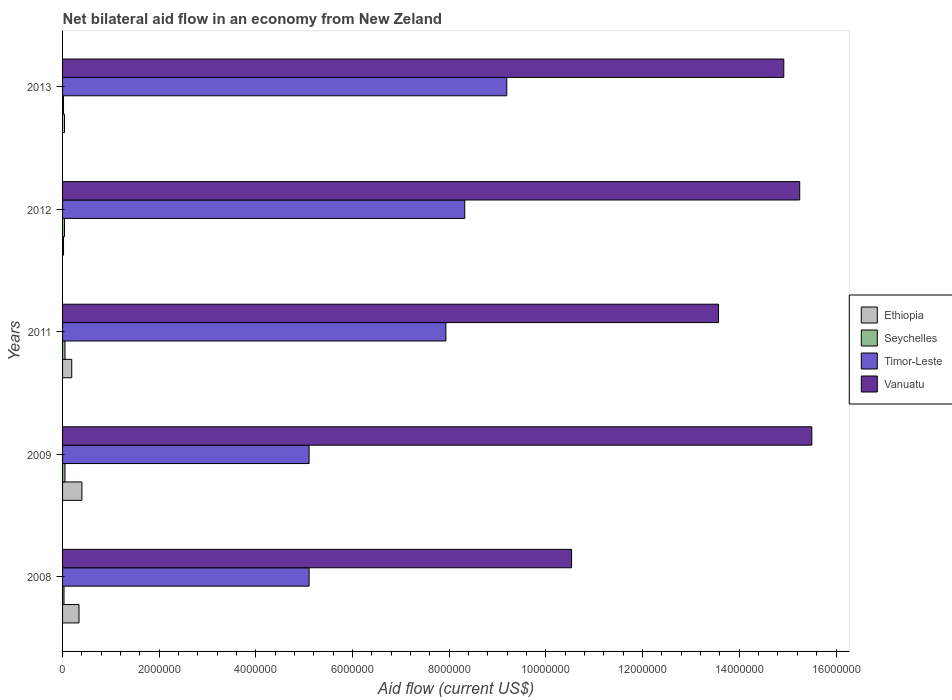How many different coloured bars are there?
Your answer should be compact. 4. Are the number of bars per tick equal to the number of legend labels?
Your response must be concise. Yes. Are the number of bars on each tick of the Y-axis equal?
Offer a very short reply. Yes. How many bars are there on the 1st tick from the top?
Your response must be concise. 4. What is the label of the 1st group of bars from the top?
Your answer should be compact. 2013. In how many cases, is the number of bars for a given year not equal to the number of legend labels?
Provide a short and direct response. 0. What is the net bilateral aid flow in Vanuatu in 2011?
Your response must be concise. 1.36e+07. Across all years, what is the maximum net bilateral aid flow in Vanuatu?
Make the answer very short. 1.55e+07. Across all years, what is the minimum net bilateral aid flow in Vanuatu?
Provide a succinct answer. 1.05e+07. What is the difference between the net bilateral aid flow in Timor-Leste in 2008 and that in 2011?
Make the answer very short. -2.83e+06. What is the difference between the net bilateral aid flow in Timor-Leste in 2009 and the net bilateral aid flow in Seychelles in 2012?
Make the answer very short. 5.06e+06. What is the average net bilateral aid flow in Timor-Leste per year?
Provide a short and direct response. 7.13e+06. In the year 2012, what is the difference between the net bilateral aid flow in Ethiopia and net bilateral aid flow in Vanuatu?
Keep it short and to the point. -1.52e+07. In how many years, is the net bilateral aid flow in Seychelles greater than 4400000 US$?
Give a very brief answer. 0. What is the ratio of the net bilateral aid flow in Timor-Leste in 2011 to that in 2012?
Ensure brevity in your answer.  0.95. What is the difference between the highest and the second highest net bilateral aid flow in Seychelles?
Make the answer very short. 0. What is the difference between the highest and the lowest net bilateral aid flow in Timor-Leste?
Offer a very short reply. 4.09e+06. Is the sum of the net bilateral aid flow in Timor-Leste in 2009 and 2012 greater than the maximum net bilateral aid flow in Ethiopia across all years?
Make the answer very short. Yes. Is it the case that in every year, the sum of the net bilateral aid flow in Seychelles and net bilateral aid flow in Ethiopia is greater than the sum of net bilateral aid flow in Vanuatu and net bilateral aid flow in Timor-Leste?
Your response must be concise. No. What does the 4th bar from the top in 2013 represents?
Your answer should be very brief. Ethiopia. What does the 3rd bar from the bottom in 2009 represents?
Your answer should be very brief. Timor-Leste. What is the difference between two consecutive major ticks on the X-axis?
Make the answer very short. 2.00e+06. Where does the legend appear in the graph?
Provide a succinct answer. Center right. How many legend labels are there?
Keep it short and to the point. 4. How are the legend labels stacked?
Give a very brief answer. Vertical. What is the title of the graph?
Your answer should be very brief. Net bilateral aid flow in an economy from New Zeland. Does "Qatar" appear as one of the legend labels in the graph?
Ensure brevity in your answer.  No. What is the label or title of the X-axis?
Offer a terse response. Aid flow (current US$). What is the label or title of the Y-axis?
Your answer should be very brief. Years. What is the Aid flow (current US$) of Timor-Leste in 2008?
Your answer should be compact. 5.10e+06. What is the Aid flow (current US$) in Vanuatu in 2008?
Keep it short and to the point. 1.05e+07. What is the Aid flow (current US$) in Seychelles in 2009?
Your answer should be very brief. 5.00e+04. What is the Aid flow (current US$) in Timor-Leste in 2009?
Ensure brevity in your answer.  5.10e+06. What is the Aid flow (current US$) in Vanuatu in 2009?
Make the answer very short. 1.55e+07. What is the Aid flow (current US$) in Ethiopia in 2011?
Your answer should be very brief. 1.90e+05. What is the Aid flow (current US$) of Timor-Leste in 2011?
Make the answer very short. 7.93e+06. What is the Aid flow (current US$) in Vanuatu in 2011?
Give a very brief answer. 1.36e+07. What is the Aid flow (current US$) in Ethiopia in 2012?
Ensure brevity in your answer.  2.00e+04. What is the Aid flow (current US$) in Timor-Leste in 2012?
Your answer should be very brief. 8.32e+06. What is the Aid flow (current US$) in Vanuatu in 2012?
Ensure brevity in your answer.  1.52e+07. What is the Aid flow (current US$) of Seychelles in 2013?
Your answer should be compact. 2.00e+04. What is the Aid flow (current US$) of Timor-Leste in 2013?
Make the answer very short. 9.19e+06. What is the Aid flow (current US$) of Vanuatu in 2013?
Offer a terse response. 1.49e+07. Across all years, what is the maximum Aid flow (current US$) of Timor-Leste?
Provide a succinct answer. 9.19e+06. Across all years, what is the maximum Aid flow (current US$) of Vanuatu?
Offer a very short reply. 1.55e+07. Across all years, what is the minimum Aid flow (current US$) of Ethiopia?
Your answer should be compact. 2.00e+04. Across all years, what is the minimum Aid flow (current US$) in Seychelles?
Provide a succinct answer. 2.00e+04. Across all years, what is the minimum Aid flow (current US$) in Timor-Leste?
Your response must be concise. 5.10e+06. Across all years, what is the minimum Aid flow (current US$) in Vanuatu?
Give a very brief answer. 1.05e+07. What is the total Aid flow (current US$) of Ethiopia in the graph?
Provide a short and direct response. 9.90e+05. What is the total Aid flow (current US$) in Seychelles in the graph?
Make the answer very short. 1.90e+05. What is the total Aid flow (current US$) of Timor-Leste in the graph?
Ensure brevity in your answer.  3.56e+07. What is the total Aid flow (current US$) of Vanuatu in the graph?
Offer a terse response. 6.98e+07. What is the difference between the Aid flow (current US$) in Ethiopia in 2008 and that in 2009?
Ensure brevity in your answer.  -6.00e+04. What is the difference between the Aid flow (current US$) in Vanuatu in 2008 and that in 2009?
Your answer should be very brief. -4.97e+06. What is the difference between the Aid flow (current US$) in Ethiopia in 2008 and that in 2011?
Give a very brief answer. 1.50e+05. What is the difference between the Aid flow (current US$) of Seychelles in 2008 and that in 2011?
Your answer should be compact. -2.00e+04. What is the difference between the Aid flow (current US$) of Timor-Leste in 2008 and that in 2011?
Offer a very short reply. -2.83e+06. What is the difference between the Aid flow (current US$) in Vanuatu in 2008 and that in 2011?
Offer a very short reply. -3.04e+06. What is the difference between the Aid flow (current US$) of Seychelles in 2008 and that in 2012?
Offer a very short reply. -10000. What is the difference between the Aid flow (current US$) in Timor-Leste in 2008 and that in 2012?
Your answer should be very brief. -3.22e+06. What is the difference between the Aid flow (current US$) of Vanuatu in 2008 and that in 2012?
Offer a terse response. -4.72e+06. What is the difference between the Aid flow (current US$) of Timor-Leste in 2008 and that in 2013?
Ensure brevity in your answer.  -4.09e+06. What is the difference between the Aid flow (current US$) in Vanuatu in 2008 and that in 2013?
Offer a very short reply. -4.39e+06. What is the difference between the Aid flow (current US$) in Ethiopia in 2009 and that in 2011?
Ensure brevity in your answer.  2.10e+05. What is the difference between the Aid flow (current US$) in Timor-Leste in 2009 and that in 2011?
Provide a short and direct response. -2.83e+06. What is the difference between the Aid flow (current US$) in Vanuatu in 2009 and that in 2011?
Offer a terse response. 1.93e+06. What is the difference between the Aid flow (current US$) of Ethiopia in 2009 and that in 2012?
Provide a succinct answer. 3.80e+05. What is the difference between the Aid flow (current US$) of Timor-Leste in 2009 and that in 2012?
Your answer should be very brief. -3.22e+06. What is the difference between the Aid flow (current US$) of Ethiopia in 2009 and that in 2013?
Give a very brief answer. 3.60e+05. What is the difference between the Aid flow (current US$) of Timor-Leste in 2009 and that in 2013?
Keep it short and to the point. -4.09e+06. What is the difference between the Aid flow (current US$) in Vanuatu in 2009 and that in 2013?
Make the answer very short. 5.80e+05. What is the difference between the Aid flow (current US$) of Ethiopia in 2011 and that in 2012?
Give a very brief answer. 1.70e+05. What is the difference between the Aid flow (current US$) of Seychelles in 2011 and that in 2012?
Offer a very short reply. 10000. What is the difference between the Aid flow (current US$) in Timor-Leste in 2011 and that in 2012?
Your answer should be very brief. -3.90e+05. What is the difference between the Aid flow (current US$) in Vanuatu in 2011 and that in 2012?
Give a very brief answer. -1.68e+06. What is the difference between the Aid flow (current US$) of Timor-Leste in 2011 and that in 2013?
Ensure brevity in your answer.  -1.26e+06. What is the difference between the Aid flow (current US$) of Vanuatu in 2011 and that in 2013?
Make the answer very short. -1.35e+06. What is the difference between the Aid flow (current US$) of Ethiopia in 2012 and that in 2013?
Make the answer very short. -2.00e+04. What is the difference between the Aid flow (current US$) in Timor-Leste in 2012 and that in 2013?
Offer a very short reply. -8.70e+05. What is the difference between the Aid flow (current US$) in Vanuatu in 2012 and that in 2013?
Your response must be concise. 3.30e+05. What is the difference between the Aid flow (current US$) in Ethiopia in 2008 and the Aid flow (current US$) in Timor-Leste in 2009?
Your answer should be very brief. -4.76e+06. What is the difference between the Aid flow (current US$) in Ethiopia in 2008 and the Aid flow (current US$) in Vanuatu in 2009?
Make the answer very short. -1.52e+07. What is the difference between the Aid flow (current US$) of Seychelles in 2008 and the Aid flow (current US$) of Timor-Leste in 2009?
Your answer should be compact. -5.07e+06. What is the difference between the Aid flow (current US$) in Seychelles in 2008 and the Aid flow (current US$) in Vanuatu in 2009?
Ensure brevity in your answer.  -1.55e+07. What is the difference between the Aid flow (current US$) of Timor-Leste in 2008 and the Aid flow (current US$) of Vanuatu in 2009?
Your response must be concise. -1.04e+07. What is the difference between the Aid flow (current US$) in Ethiopia in 2008 and the Aid flow (current US$) in Seychelles in 2011?
Keep it short and to the point. 2.90e+05. What is the difference between the Aid flow (current US$) in Ethiopia in 2008 and the Aid flow (current US$) in Timor-Leste in 2011?
Give a very brief answer. -7.59e+06. What is the difference between the Aid flow (current US$) of Ethiopia in 2008 and the Aid flow (current US$) of Vanuatu in 2011?
Provide a succinct answer. -1.32e+07. What is the difference between the Aid flow (current US$) of Seychelles in 2008 and the Aid flow (current US$) of Timor-Leste in 2011?
Ensure brevity in your answer.  -7.90e+06. What is the difference between the Aid flow (current US$) of Seychelles in 2008 and the Aid flow (current US$) of Vanuatu in 2011?
Your answer should be very brief. -1.35e+07. What is the difference between the Aid flow (current US$) of Timor-Leste in 2008 and the Aid flow (current US$) of Vanuatu in 2011?
Give a very brief answer. -8.47e+06. What is the difference between the Aid flow (current US$) in Ethiopia in 2008 and the Aid flow (current US$) in Timor-Leste in 2012?
Your answer should be very brief. -7.98e+06. What is the difference between the Aid flow (current US$) of Ethiopia in 2008 and the Aid flow (current US$) of Vanuatu in 2012?
Provide a short and direct response. -1.49e+07. What is the difference between the Aid flow (current US$) of Seychelles in 2008 and the Aid flow (current US$) of Timor-Leste in 2012?
Your response must be concise. -8.29e+06. What is the difference between the Aid flow (current US$) in Seychelles in 2008 and the Aid flow (current US$) in Vanuatu in 2012?
Give a very brief answer. -1.52e+07. What is the difference between the Aid flow (current US$) in Timor-Leste in 2008 and the Aid flow (current US$) in Vanuatu in 2012?
Keep it short and to the point. -1.02e+07. What is the difference between the Aid flow (current US$) of Ethiopia in 2008 and the Aid flow (current US$) of Seychelles in 2013?
Provide a succinct answer. 3.20e+05. What is the difference between the Aid flow (current US$) of Ethiopia in 2008 and the Aid flow (current US$) of Timor-Leste in 2013?
Your response must be concise. -8.85e+06. What is the difference between the Aid flow (current US$) in Ethiopia in 2008 and the Aid flow (current US$) in Vanuatu in 2013?
Keep it short and to the point. -1.46e+07. What is the difference between the Aid flow (current US$) in Seychelles in 2008 and the Aid flow (current US$) in Timor-Leste in 2013?
Your answer should be very brief. -9.16e+06. What is the difference between the Aid flow (current US$) of Seychelles in 2008 and the Aid flow (current US$) of Vanuatu in 2013?
Make the answer very short. -1.49e+07. What is the difference between the Aid flow (current US$) of Timor-Leste in 2008 and the Aid flow (current US$) of Vanuatu in 2013?
Your answer should be very brief. -9.82e+06. What is the difference between the Aid flow (current US$) in Ethiopia in 2009 and the Aid flow (current US$) in Timor-Leste in 2011?
Keep it short and to the point. -7.53e+06. What is the difference between the Aid flow (current US$) of Ethiopia in 2009 and the Aid flow (current US$) of Vanuatu in 2011?
Ensure brevity in your answer.  -1.32e+07. What is the difference between the Aid flow (current US$) of Seychelles in 2009 and the Aid flow (current US$) of Timor-Leste in 2011?
Provide a short and direct response. -7.88e+06. What is the difference between the Aid flow (current US$) in Seychelles in 2009 and the Aid flow (current US$) in Vanuatu in 2011?
Your answer should be compact. -1.35e+07. What is the difference between the Aid flow (current US$) in Timor-Leste in 2009 and the Aid flow (current US$) in Vanuatu in 2011?
Make the answer very short. -8.47e+06. What is the difference between the Aid flow (current US$) in Ethiopia in 2009 and the Aid flow (current US$) in Timor-Leste in 2012?
Your answer should be very brief. -7.92e+06. What is the difference between the Aid flow (current US$) in Ethiopia in 2009 and the Aid flow (current US$) in Vanuatu in 2012?
Ensure brevity in your answer.  -1.48e+07. What is the difference between the Aid flow (current US$) of Seychelles in 2009 and the Aid flow (current US$) of Timor-Leste in 2012?
Ensure brevity in your answer.  -8.27e+06. What is the difference between the Aid flow (current US$) of Seychelles in 2009 and the Aid flow (current US$) of Vanuatu in 2012?
Ensure brevity in your answer.  -1.52e+07. What is the difference between the Aid flow (current US$) of Timor-Leste in 2009 and the Aid flow (current US$) of Vanuatu in 2012?
Provide a short and direct response. -1.02e+07. What is the difference between the Aid flow (current US$) in Ethiopia in 2009 and the Aid flow (current US$) in Timor-Leste in 2013?
Provide a short and direct response. -8.79e+06. What is the difference between the Aid flow (current US$) of Ethiopia in 2009 and the Aid flow (current US$) of Vanuatu in 2013?
Offer a terse response. -1.45e+07. What is the difference between the Aid flow (current US$) in Seychelles in 2009 and the Aid flow (current US$) in Timor-Leste in 2013?
Ensure brevity in your answer.  -9.14e+06. What is the difference between the Aid flow (current US$) in Seychelles in 2009 and the Aid flow (current US$) in Vanuatu in 2013?
Ensure brevity in your answer.  -1.49e+07. What is the difference between the Aid flow (current US$) in Timor-Leste in 2009 and the Aid flow (current US$) in Vanuatu in 2013?
Make the answer very short. -9.82e+06. What is the difference between the Aid flow (current US$) of Ethiopia in 2011 and the Aid flow (current US$) of Timor-Leste in 2012?
Provide a short and direct response. -8.13e+06. What is the difference between the Aid flow (current US$) in Ethiopia in 2011 and the Aid flow (current US$) in Vanuatu in 2012?
Provide a succinct answer. -1.51e+07. What is the difference between the Aid flow (current US$) of Seychelles in 2011 and the Aid flow (current US$) of Timor-Leste in 2012?
Provide a succinct answer. -8.27e+06. What is the difference between the Aid flow (current US$) of Seychelles in 2011 and the Aid flow (current US$) of Vanuatu in 2012?
Keep it short and to the point. -1.52e+07. What is the difference between the Aid flow (current US$) of Timor-Leste in 2011 and the Aid flow (current US$) of Vanuatu in 2012?
Ensure brevity in your answer.  -7.32e+06. What is the difference between the Aid flow (current US$) of Ethiopia in 2011 and the Aid flow (current US$) of Timor-Leste in 2013?
Your response must be concise. -9.00e+06. What is the difference between the Aid flow (current US$) in Ethiopia in 2011 and the Aid flow (current US$) in Vanuatu in 2013?
Provide a succinct answer. -1.47e+07. What is the difference between the Aid flow (current US$) in Seychelles in 2011 and the Aid flow (current US$) in Timor-Leste in 2013?
Provide a short and direct response. -9.14e+06. What is the difference between the Aid flow (current US$) in Seychelles in 2011 and the Aid flow (current US$) in Vanuatu in 2013?
Provide a short and direct response. -1.49e+07. What is the difference between the Aid flow (current US$) of Timor-Leste in 2011 and the Aid flow (current US$) of Vanuatu in 2013?
Provide a short and direct response. -6.99e+06. What is the difference between the Aid flow (current US$) of Ethiopia in 2012 and the Aid flow (current US$) of Seychelles in 2013?
Make the answer very short. 0. What is the difference between the Aid flow (current US$) of Ethiopia in 2012 and the Aid flow (current US$) of Timor-Leste in 2013?
Make the answer very short. -9.17e+06. What is the difference between the Aid flow (current US$) in Ethiopia in 2012 and the Aid flow (current US$) in Vanuatu in 2013?
Keep it short and to the point. -1.49e+07. What is the difference between the Aid flow (current US$) of Seychelles in 2012 and the Aid flow (current US$) of Timor-Leste in 2013?
Your answer should be compact. -9.15e+06. What is the difference between the Aid flow (current US$) in Seychelles in 2012 and the Aid flow (current US$) in Vanuatu in 2013?
Offer a very short reply. -1.49e+07. What is the difference between the Aid flow (current US$) in Timor-Leste in 2012 and the Aid flow (current US$) in Vanuatu in 2013?
Your response must be concise. -6.60e+06. What is the average Aid flow (current US$) of Ethiopia per year?
Offer a very short reply. 1.98e+05. What is the average Aid flow (current US$) of Seychelles per year?
Give a very brief answer. 3.80e+04. What is the average Aid flow (current US$) of Timor-Leste per year?
Offer a very short reply. 7.13e+06. What is the average Aid flow (current US$) in Vanuatu per year?
Ensure brevity in your answer.  1.40e+07. In the year 2008, what is the difference between the Aid flow (current US$) in Ethiopia and Aid flow (current US$) in Seychelles?
Provide a short and direct response. 3.10e+05. In the year 2008, what is the difference between the Aid flow (current US$) in Ethiopia and Aid flow (current US$) in Timor-Leste?
Offer a terse response. -4.76e+06. In the year 2008, what is the difference between the Aid flow (current US$) of Ethiopia and Aid flow (current US$) of Vanuatu?
Make the answer very short. -1.02e+07. In the year 2008, what is the difference between the Aid flow (current US$) of Seychelles and Aid flow (current US$) of Timor-Leste?
Provide a succinct answer. -5.07e+06. In the year 2008, what is the difference between the Aid flow (current US$) in Seychelles and Aid flow (current US$) in Vanuatu?
Your answer should be very brief. -1.05e+07. In the year 2008, what is the difference between the Aid flow (current US$) in Timor-Leste and Aid flow (current US$) in Vanuatu?
Keep it short and to the point. -5.43e+06. In the year 2009, what is the difference between the Aid flow (current US$) of Ethiopia and Aid flow (current US$) of Seychelles?
Your answer should be compact. 3.50e+05. In the year 2009, what is the difference between the Aid flow (current US$) in Ethiopia and Aid flow (current US$) in Timor-Leste?
Your answer should be compact. -4.70e+06. In the year 2009, what is the difference between the Aid flow (current US$) in Ethiopia and Aid flow (current US$) in Vanuatu?
Offer a terse response. -1.51e+07. In the year 2009, what is the difference between the Aid flow (current US$) in Seychelles and Aid flow (current US$) in Timor-Leste?
Your response must be concise. -5.05e+06. In the year 2009, what is the difference between the Aid flow (current US$) of Seychelles and Aid flow (current US$) of Vanuatu?
Keep it short and to the point. -1.54e+07. In the year 2009, what is the difference between the Aid flow (current US$) in Timor-Leste and Aid flow (current US$) in Vanuatu?
Your answer should be compact. -1.04e+07. In the year 2011, what is the difference between the Aid flow (current US$) of Ethiopia and Aid flow (current US$) of Seychelles?
Offer a terse response. 1.40e+05. In the year 2011, what is the difference between the Aid flow (current US$) in Ethiopia and Aid flow (current US$) in Timor-Leste?
Provide a succinct answer. -7.74e+06. In the year 2011, what is the difference between the Aid flow (current US$) in Ethiopia and Aid flow (current US$) in Vanuatu?
Keep it short and to the point. -1.34e+07. In the year 2011, what is the difference between the Aid flow (current US$) in Seychelles and Aid flow (current US$) in Timor-Leste?
Give a very brief answer. -7.88e+06. In the year 2011, what is the difference between the Aid flow (current US$) in Seychelles and Aid flow (current US$) in Vanuatu?
Offer a terse response. -1.35e+07. In the year 2011, what is the difference between the Aid flow (current US$) of Timor-Leste and Aid flow (current US$) of Vanuatu?
Your answer should be compact. -5.64e+06. In the year 2012, what is the difference between the Aid flow (current US$) in Ethiopia and Aid flow (current US$) in Timor-Leste?
Ensure brevity in your answer.  -8.30e+06. In the year 2012, what is the difference between the Aid flow (current US$) of Ethiopia and Aid flow (current US$) of Vanuatu?
Provide a succinct answer. -1.52e+07. In the year 2012, what is the difference between the Aid flow (current US$) in Seychelles and Aid flow (current US$) in Timor-Leste?
Give a very brief answer. -8.28e+06. In the year 2012, what is the difference between the Aid flow (current US$) of Seychelles and Aid flow (current US$) of Vanuatu?
Provide a short and direct response. -1.52e+07. In the year 2012, what is the difference between the Aid flow (current US$) of Timor-Leste and Aid flow (current US$) of Vanuatu?
Your answer should be very brief. -6.93e+06. In the year 2013, what is the difference between the Aid flow (current US$) in Ethiopia and Aid flow (current US$) in Timor-Leste?
Keep it short and to the point. -9.15e+06. In the year 2013, what is the difference between the Aid flow (current US$) of Ethiopia and Aid flow (current US$) of Vanuatu?
Your response must be concise. -1.49e+07. In the year 2013, what is the difference between the Aid flow (current US$) of Seychelles and Aid flow (current US$) of Timor-Leste?
Ensure brevity in your answer.  -9.17e+06. In the year 2013, what is the difference between the Aid flow (current US$) of Seychelles and Aid flow (current US$) of Vanuatu?
Your answer should be very brief. -1.49e+07. In the year 2013, what is the difference between the Aid flow (current US$) of Timor-Leste and Aid flow (current US$) of Vanuatu?
Provide a short and direct response. -5.73e+06. What is the ratio of the Aid flow (current US$) in Ethiopia in 2008 to that in 2009?
Your answer should be compact. 0.85. What is the ratio of the Aid flow (current US$) of Seychelles in 2008 to that in 2009?
Make the answer very short. 0.6. What is the ratio of the Aid flow (current US$) of Vanuatu in 2008 to that in 2009?
Your response must be concise. 0.68. What is the ratio of the Aid flow (current US$) of Ethiopia in 2008 to that in 2011?
Offer a terse response. 1.79. What is the ratio of the Aid flow (current US$) in Timor-Leste in 2008 to that in 2011?
Ensure brevity in your answer.  0.64. What is the ratio of the Aid flow (current US$) of Vanuatu in 2008 to that in 2011?
Make the answer very short. 0.78. What is the ratio of the Aid flow (current US$) in Ethiopia in 2008 to that in 2012?
Provide a short and direct response. 17. What is the ratio of the Aid flow (current US$) in Timor-Leste in 2008 to that in 2012?
Provide a succinct answer. 0.61. What is the ratio of the Aid flow (current US$) of Vanuatu in 2008 to that in 2012?
Offer a very short reply. 0.69. What is the ratio of the Aid flow (current US$) of Timor-Leste in 2008 to that in 2013?
Provide a succinct answer. 0.56. What is the ratio of the Aid flow (current US$) of Vanuatu in 2008 to that in 2013?
Your response must be concise. 0.71. What is the ratio of the Aid flow (current US$) in Ethiopia in 2009 to that in 2011?
Provide a short and direct response. 2.11. What is the ratio of the Aid flow (current US$) of Seychelles in 2009 to that in 2011?
Offer a very short reply. 1. What is the ratio of the Aid flow (current US$) in Timor-Leste in 2009 to that in 2011?
Your answer should be very brief. 0.64. What is the ratio of the Aid flow (current US$) of Vanuatu in 2009 to that in 2011?
Give a very brief answer. 1.14. What is the ratio of the Aid flow (current US$) of Timor-Leste in 2009 to that in 2012?
Make the answer very short. 0.61. What is the ratio of the Aid flow (current US$) in Vanuatu in 2009 to that in 2012?
Ensure brevity in your answer.  1.02. What is the ratio of the Aid flow (current US$) of Timor-Leste in 2009 to that in 2013?
Offer a terse response. 0.56. What is the ratio of the Aid flow (current US$) of Vanuatu in 2009 to that in 2013?
Make the answer very short. 1.04. What is the ratio of the Aid flow (current US$) in Ethiopia in 2011 to that in 2012?
Your answer should be very brief. 9.5. What is the ratio of the Aid flow (current US$) of Timor-Leste in 2011 to that in 2012?
Keep it short and to the point. 0.95. What is the ratio of the Aid flow (current US$) in Vanuatu in 2011 to that in 2012?
Give a very brief answer. 0.89. What is the ratio of the Aid flow (current US$) of Ethiopia in 2011 to that in 2013?
Offer a very short reply. 4.75. What is the ratio of the Aid flow (current US$) in Seychelles in 2011 to that in 2013?
Your response must be concise. 2.5. What is the ratio of the Aid flow (current US$) in Timor-Leste in 2011 to that in 2013?
Provide a short and direct response. 0.86. What is the ratio of the Aid flow (current US$) in Vanuatu in 2011 to that in 2013?
Offer a very short reply. 0.91. What is the ratio of the Aid flow (current US$) in Seychelles in 2012 to that in 2013?
Your answer should be compact. 2. What is the ratio of the Aid flow (current US$) in Timor-Leste in 2012 to that in 2013?
Your response must be concise. 0.91. What is the ratio of the Aid flow (current US$) of Vanuatu in 2012 to that in 2013?
Keep it short and to the point. 1.02. What is the difference between the highest and the second highest Aid flow (current US$) in Ethiopia?
Your answer should be very brief. 6.00e+04. What is the difference between the highest and the second highest Aid flow (current US$) in Timor-Leste?
Your response must be concise. 8.70e+05. What is the difference between the highest and the lowest Aid flow (current US$) in Ethiopia?
Give a very brief answer. 3.80e+05. What is the difference between the highest and the lowest Aid flow (current US$) in Seychelles?
Give a very brief answer. 3.00e+04. What is the difference between the highest and the lowest Aid flow (current US$) in Timor-Leste?
Your answer should be very brief. 4.09e+06. What is the difference between the highest and the lowest Aid flow (current US$) in Vanuatu?
Your response must be concise. 4.97e+06. 